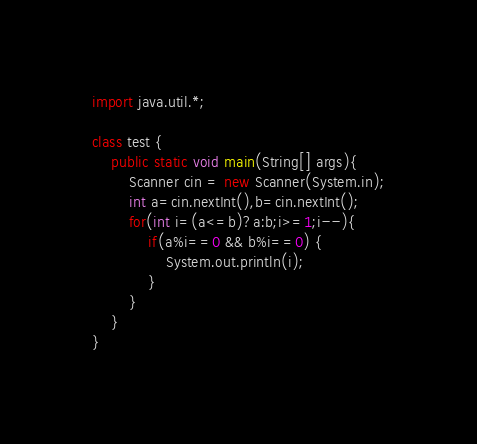Convert code to text. <code><loc_0><loc_0><loc_500><loc_500><_Java_>
import java.util.*;

class test {
	public static void main(String[] args){
		Scanner cin = new Scanner(System.in);
		int a=cin.nextInt(),b=cin.nextInt();
		for(int i=(a<=b)?a:b;i>=1;i--){
			if(a%i==0 && b%i==0) {
				System.out.println(i);
			}
		}
	}
}
</code> 